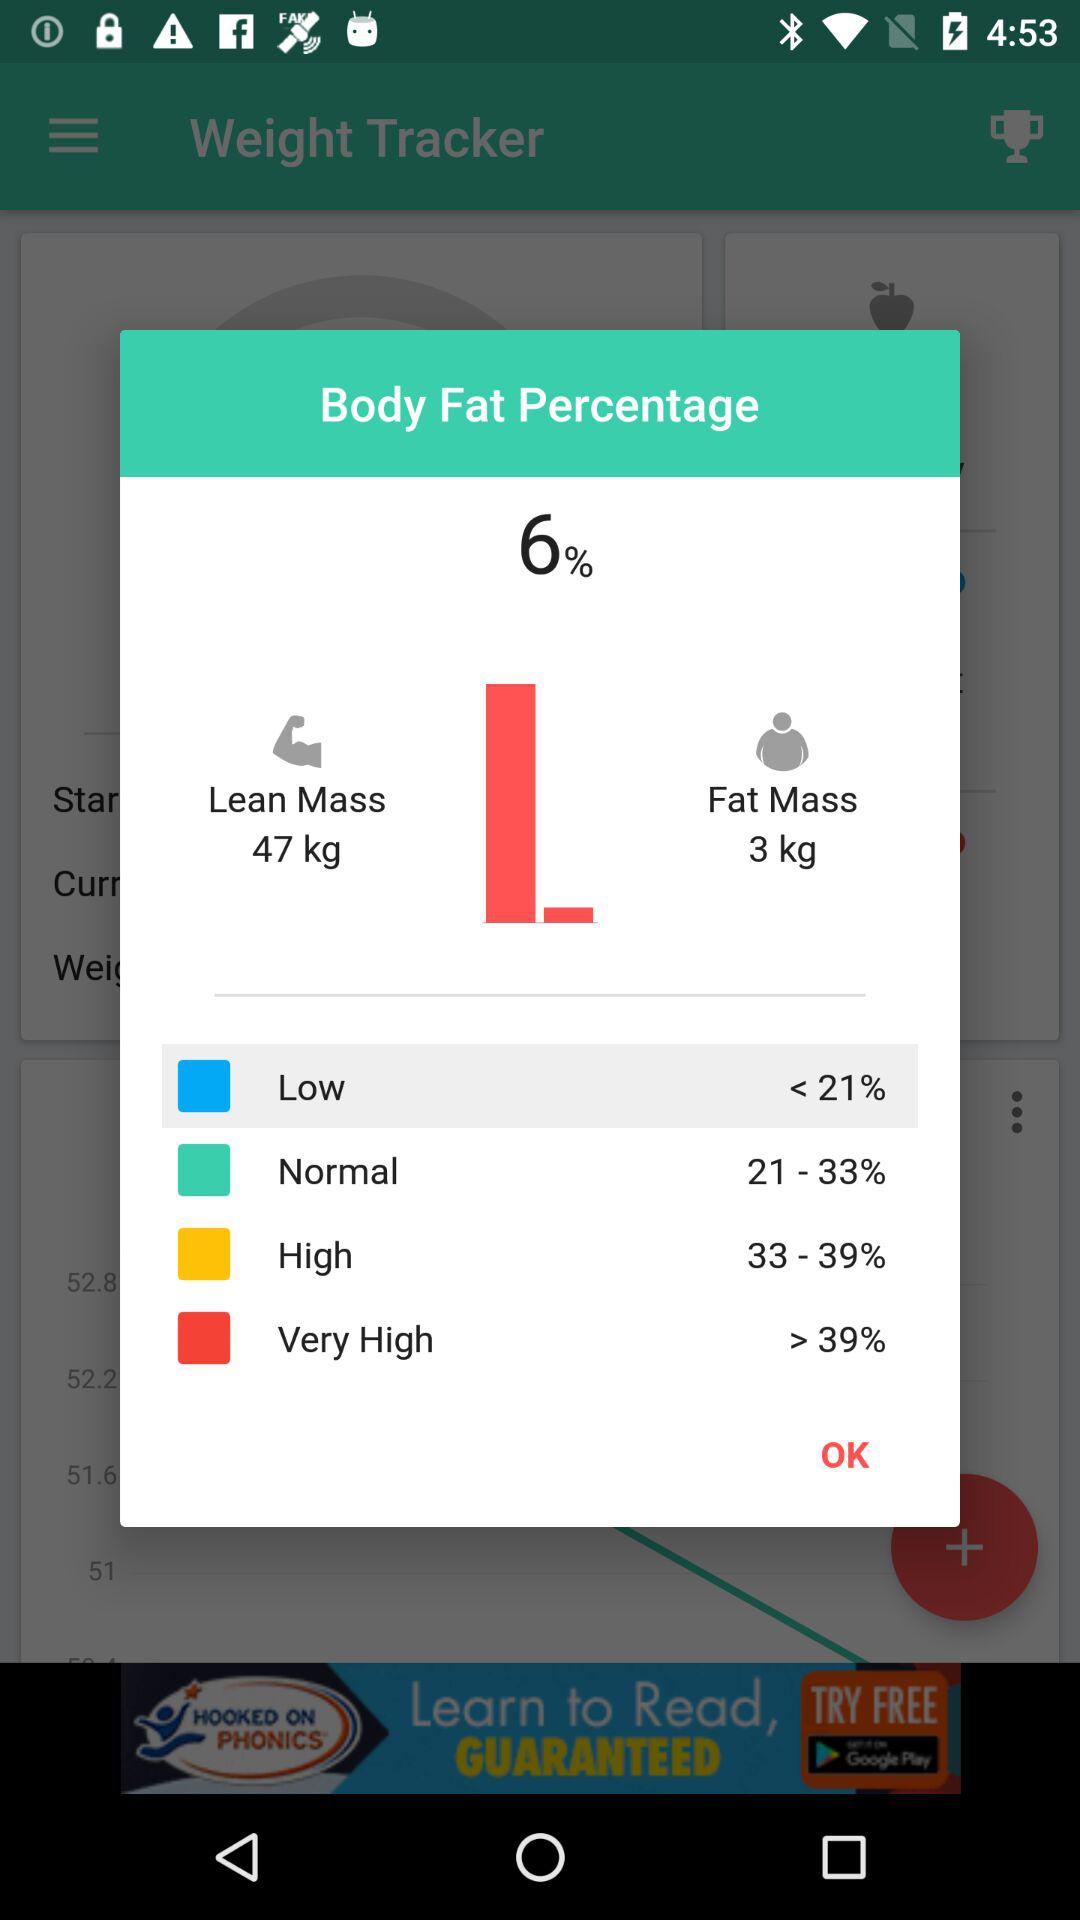What is the percentage of body fat? The percentage of body fat is 6. 